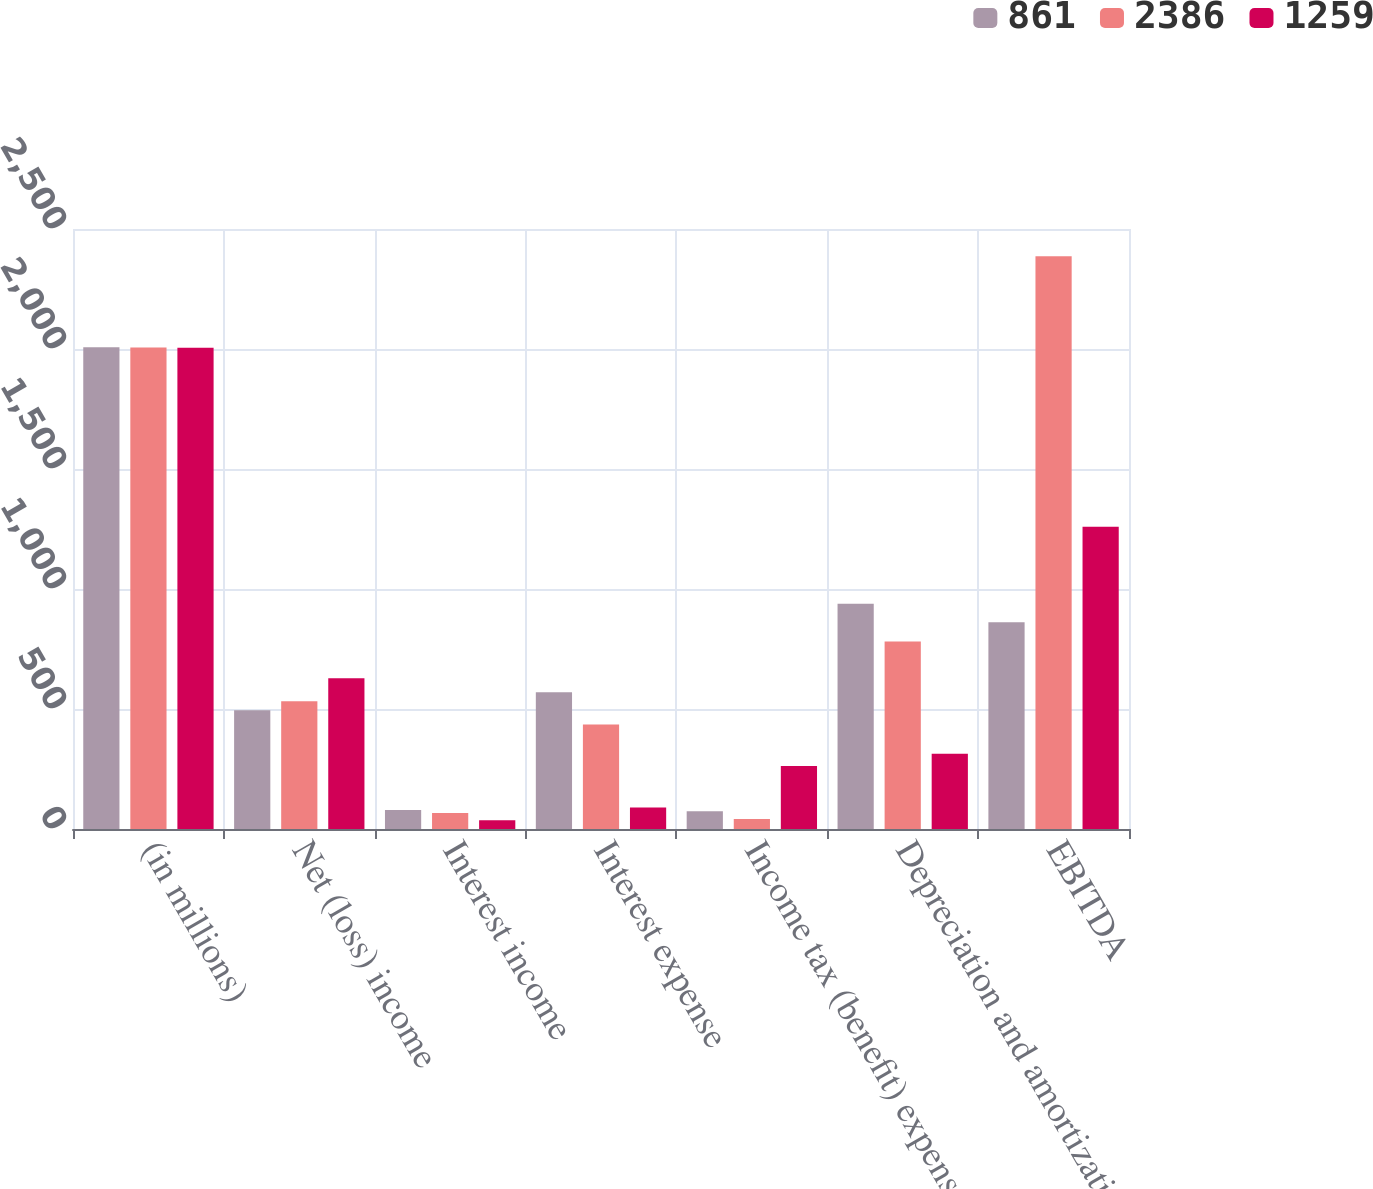Convert chart to OTSL. <chart><loc_0><loc_0><loc_500><loc_500><stacked_bar_chart><ecel><fcel>(in millions)<fcel>Net (loss) income<fcel>Interest income<fcel>Interest expense<fcel>Income tax (benefit) expense<fcel>Depreciation and amortization<fcel>EBITDA<nl><fcel>861<fcel>2007<fcel>495<fcel>79<fcel>570<fcel>74<fcel>939<fcel>861<nl><fcel>2386<fcel>2006<fcel>532.5<fcel>67<fcel>435<fcel>42<fcel>781<fcel>2386<nl><fcel>1259<fcel>2005<fcel>628<fcel>36<fcel>90<fcel>263<fcel>314<fcel>1259<nl></chart> 